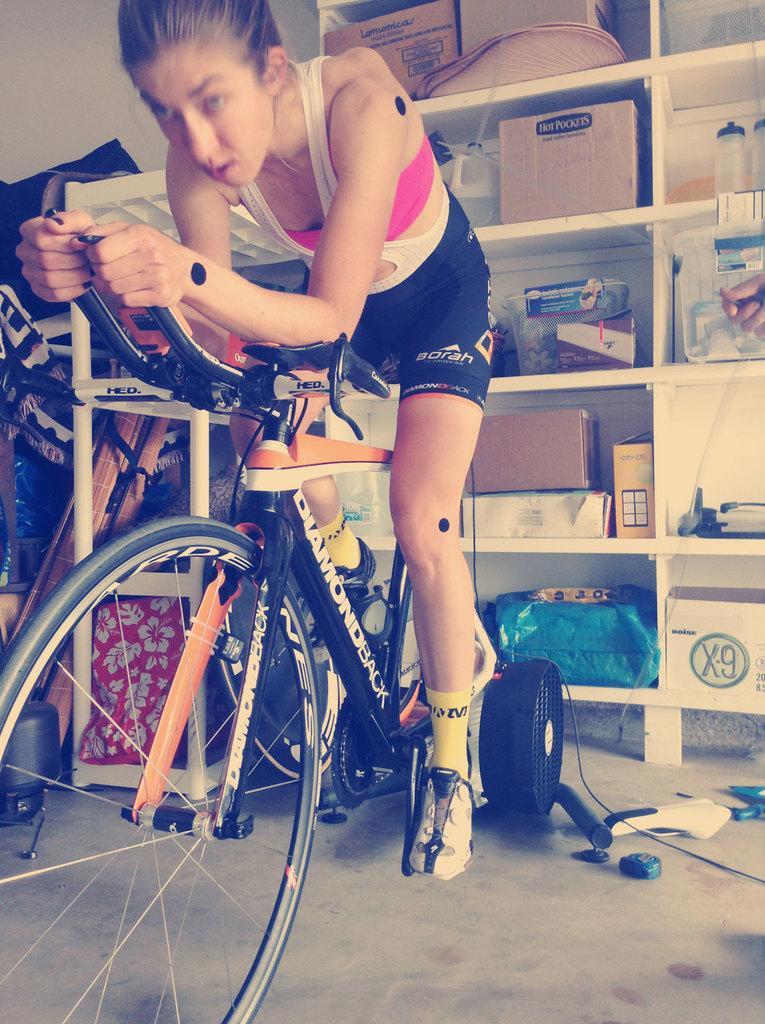In one or two sentences, can you explain what this image depicts? In the image a lady is riding a cycle. In the background there is a rack with cartons, bottles and few other stuffs. 